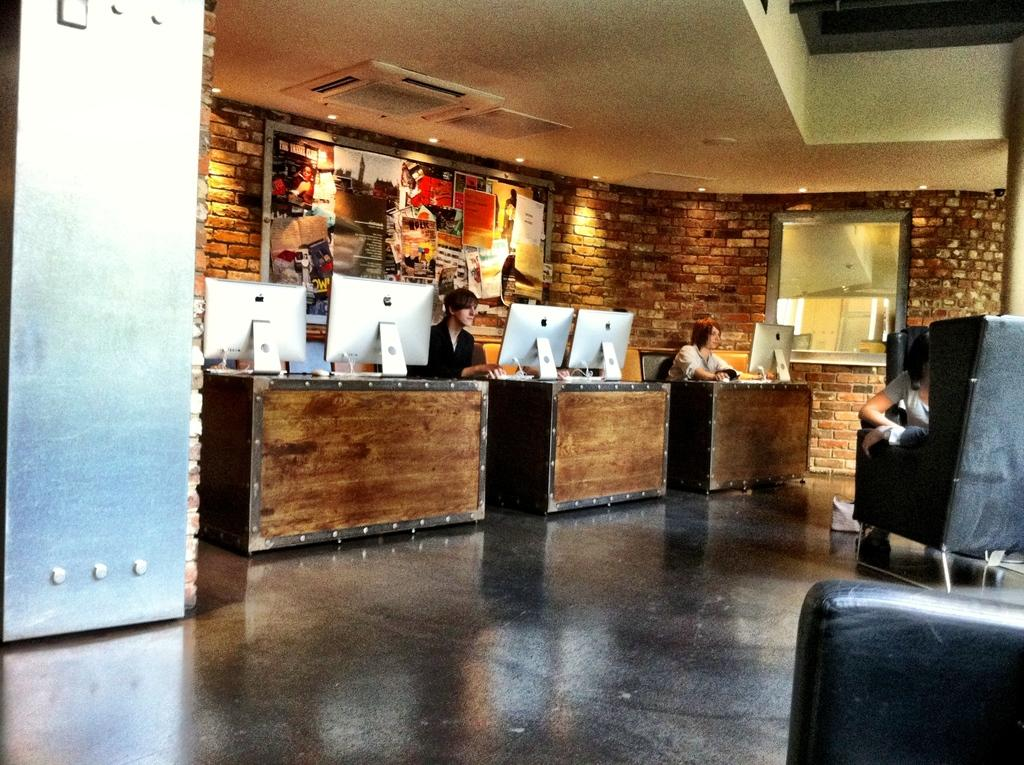How many people are in the image? There are two people in the image. What are the two people doing in the image? The two people are sitting on a chair. What is in front of the chair? There is a table in front of the chair. What type of orange is being played by the band in the image? There is no band or orange present in the image. 